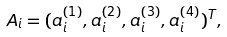<formula> <loc_0><loc_0><loc_500><loc_500>A _ { i } = ( a ^ { ( 1 ) } _ { i } , a ^ { ( 2 ) } _ { i } , a ^ { ( 3 ) } _ { i } , a ^ { ( 4 ) } _ { i } ) ^ { T } ,</formula> 